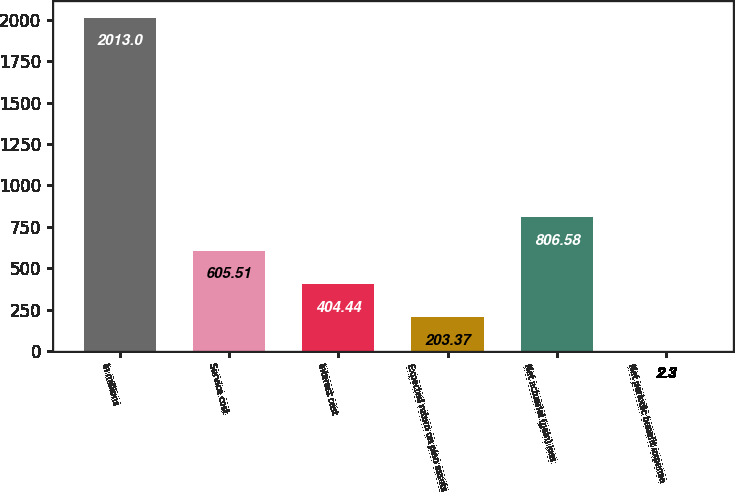<chart> <loc_0><loc_0><loc_500><loc_500><bar_chart><fcel>In millions<fcel>Service cost<fcel>Interest cost<fcel>Expected return on plan assets<fcel>Net actuarial (gain) loss<fcel>Net periodic benefit expense<nl><fcel>2013<fcel>605.51<fcel>404.44<fcel>203.37<fcel>806.58<fcel>2.3<nl></chart> 